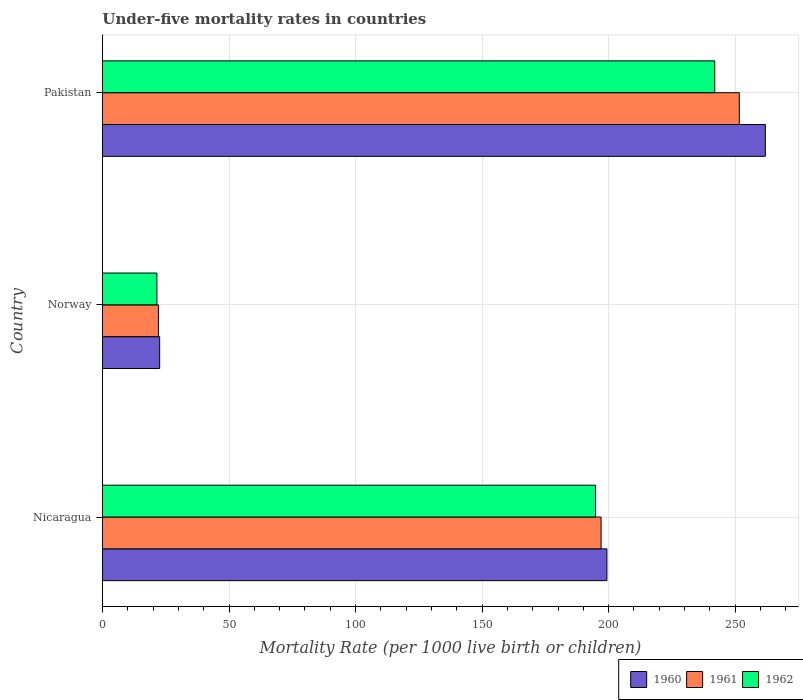Are the number of bars on each tick of the Y-axis equal?
Offer a terse response. Yes. What is the label of the 3rd group of bars from the top?
Ensure brevity in your answer.  Nicaragua. In how many cases, is the number of bars for a given country not equal to the number of legend labels?
Your answer should be compact. 0. What is the under-five mortality rate in 1961 in Nicaragua?
Your answer should be compact. 197. Across all countries, what is the maximum under-five mortality rate in 1960?
Keep it short and to the point. 261.9. Across all countries, what is the minimum under-five mortality rate in 1962?
Provide a short and direct response. 21.5. In which country was the under-five mortality rate in 1961 maximum?
Offer a terse response. Pakistan. What is the total under-five mortality rate in 1962 in the graph?
Provide a succinct answer. 458.2. What is the difference between the under-five mortality rate in 1962 in Nicaragua and that in Norway?
Give a very brief answer. 173.3. What is the difference between the under-five mortality rate in 1961 in Nicaragua and the under-five mortality rate in 1960 in Norway?
Provide a succinct answer. 174.4. What is the average under-five mortality rate in 1961 per country?
Keep it short and to the point. 156.9. What is the difference between the under-five mortality rate in 1962 and under-five mortality rate in 1961 in Nicaragua?
Offer a very short reply. -2.2. What is the ratio of the under-five mortality rate in 1962 in Nicaragua to that in Norway?
Your response must be concise. 9.06. What is the difference between the highest and the second highest under-five mortality rate in 1962?
Give a very brief answer. 47.1. What is the difference between the highest and the lowest under-five mortality rate in 1960?
Offer a terse response. 239.3. Is the sum of the under-five mortality rate in 1961 in Nicaragua and Norway greater than the maximum under-five mortality rate in 1962 across all countries?
Give a very brief answer. No. How many bars are there?
Provide a succinct answer. 9. Are all the bars in the graph horizontal?
Your answer should be compact. Yes. What is the difference between two consecutive major ticks on the X-axis?
Offer a very short reply. 50. Are the values on the major ticks of X-axis written in scientific E-notation?
Your answer should be very brief. No. How are the legend labels stacked?
Your answer should be very brief. Horizontal. What is the title of the graph?
Make the answer very short. Under-five mortality rates in countries. Does "2008" appear as one of the legend labels in the graph?
Offer a very short reply. No. What is the label or title of the X-axis?
Your answer should be very brief. Mortality Rate (per 1000 live birth or children). What is the label or title of the Y-axis?
Provide a short and direct response. Country. What is the Mortality Rate (per 1000 live birth or children) in 1960 in Nicaragua?
Keep it short and to the point. 199.3. What is the Mortality Rate (per 1000 live birth or children) of 1961 in Nicaragua?
Keep it short and to the point. 197. What is the Mortality Rate (per 1000 live birth or children) in 1962 in Nicaragua?
Ensure brevity in your answer.  194.8. What is the Mortality Rate (per 1000 live birth or children) of 1960 in Norway?
Your answer should be compact. 22.6. What is the Mortality Rate (per 1000 live birth or children) of 1961 in Norway?
Provide a succinct answer. 22.1. What is the Mortality Rate (per 1000 live birth or children) of 1960 in Pakistan?
Make the answer very short. 261.9. What is the Mortality Rate (per 1000 live birth or children) in 1961 in Pakistan?
Provide a succinct answer. 251.6. What is the Mortality Rate (per 1000 live birth or children) in 1962 in Pakistan?
Ensure brevity in your answer.  241.9. Across all countries, what is the maximum Mortality Rate (per 1000 live birth or children) in 1960?
Provide a succinct answer. 261.9. Across all countries, what is the maximum Mortality Rate (per 1000 live birth or children) of 1961?
Offer a very short reply. 251.6. Across all countries, what is the maximum Mortality Rate (per 1000 live birth or children) of 1962?
Offer a very short reply. 241.9. Across all countries, what is the minimum Mortality Rate (per 1000 live birth or children) of 1960?
Keep it short and to the point. 22.6. Across all countries, what is the minimum Mortality Rate (per 1000 live birth or children) of 1961?
Give a very brief answer. 22.1. Across all countries, what is the minimum Mortality Rate (per 1000 live birth or children) in 1962?
Provide a succinct answer. 21.5. What is the total Mortality Rate (per 1000 live birth or children) of 1960 in the graph?
Give a very brief answer. 483.8. What is the total Mortality Rate (per 1000 live birth or children) of 1961 in the graph?
Your answer should be very brief. 470.7. What is the total Mortality Rate (per 1000 live birth or children) in 1962 in the graph?
Your response must be concise. 458.2. What is the difference between the Mortality Rate (per 1000 live birth or children) in 1960 in Nicaragua and that in Norway?
Provide a succinct answer. 176.7. What is the difference between the Mortality Rate (per 1000 live birth or children) in 1961 in Nicaragua and that in Norway?
Make the answer very short. 174.9. What is the difference between the Mortality Rate (per 1000 live birth or children) in 1962 in Nicaragua and that in Norway?
Ensure brevity in your answer.  173.3. What is the difference between the Mortality Rate (per 1000 live birth or children) of 1960 in Nicaragua and that in Pakistan?
Ensure brevity in your answer.  -62.6. What is the difference between the Mortality Rate (per 1000 live birth or children) of 1961 in Nicaragua and that in Pakistan?
Provide a short and direct response. -54.6. What is the difference between the Mortality Rate (per 1000 live birth or children) of 1962 in Nicaragua and that in Pakistan?
Offer a terse response. -47.1. What is the difference between the Mortality Rate (per 1000 live birth or children) of 1960 in Norway and that in Pakistan?
Ensure brevity in your answer.  -239.3. What is the difference between the Mortality Rate (per 1000 live birth or children) of 1961 in Norway and that in Pakistan?
Your response must be concise. -229.5. What is the difference between the Mortality Rate (per 1000 live birth or children) in 1962 in Norway and that in Pakistan?
Offer a very short reply. -220.4. What is the difference between the Mortality Rate (per 1000 live birth or children) in 1960 in Nicaragua and the Mortality Rate (per 1000 live birth or children) in 1961 in Norway?
Ensure brevity in your answer.  177.2. What is the difference between the Mortality Rate (per 1000 live birth or children) of 1960 in Nicaragua and the Mortality Rate (per 1000 live birth or children) of 1962 in Norway?
Your answer should be compact. 177.8. What is the difference between the Mortality Rate (per 1000 live birth or children) of 1961 in Nicaragua and the Mortality Rate (per 1000 live birth or children) of 1962 in Norway?
Your answer should be very brief. 175.5. What is the difference between the Mortality Rate (per 1000 live birth or children) of 1960 in Nicaragua and the Mortality Rate (per 1000 live birth or children) of 1961 in Pakistan?
Keep it short and to the point. -52.3. What is the difference between the Mortality Rate (per 1000 live birth or children) of 1960 in Nicaragua and the Mortality Rate (per 1000 live birth or children) of 1962 in Pakistan?
Offer a terse response. -42.6. What is the difference between the Mortality Rate (per 1000 live birth or children) in 1961 in Nicaragua and the Mortality Rate (per 1000 live birth or children) in 1962 in Pakistan?
Offer a very short reply. -44.9. What is the difference between the Mortality Rate (per 1000 live birth or children) in 1960 in Norway and the Mortality Rate (per 1000 live birth or children) in 1961 in Pakistan?
Make the answer very short. -229. What is the difference between the Mortality Rate (per 1000 live birth or children) of 1960 in Norway and the Mortality Rate (per 1000 live birth or children) of 1962 in Pakistan?
Keep it short and to the point. -219.3. What is the difference between the Mortality Rate (per 1000 live birth or children) of 1961 in Norway and the Mortality Rate (per 1000 live birth or children) of 1962 in Pakistan?
Ensure brevity in your answer.  -219.8. What is the average Mortality Rate (per 1000 live birth or children) in 1960 per country?
Your answer should be very brief. 161.27. What is the average Mortality Rate (per 1000 live birth or children) of 1961 per country?
Provide a succinct answer. 156.9. What is the average Mortality Rate (per 1000 live birth or children) in 1962 per country?
Provide a succinct answer. 152.73. What is the difference between the Mortality Rate (per 1000 live birth or children) of 1960 and Mortality Rate (per 1000 live birth or children) of 1962 in Nicaragua?
Your answer should be compact. 4.5. What is the difference between the Mortality Rate (per 1000 live birth or children) of 1961 and Mortality Rate (per 1000 live birth or children) of 1962 in Nicaragua?
Provide a succinct answer. 2.2. What is the difference between the Mortality Rate (per 1000 live birth or children) of 1960 and Mortality Rate (per 1000 live birth or children) of 1962 in Norway?
Provide a short and direct response. 1.1. What is the difference between the Mortality Rate (per 1000 live birth or children) of 1961 and Mortality Rate (per 1000 live birth or children) of 1962 in Pakistan?
Your answer should be very brief. 9.7. What is the ratio of the Mortality Rate (per 1000 live birth or children) in 1960 in Nicaragua to that in Norway?
Your answer should be very brief. 8.82. What is the ratio of the Mortality Rate (per 1000 live birth or children) of 1961 in Nicaragua to that in Norway?
Offer a very short reply. 8.91. What is the ratio of the Mortality Rate (per 1000 live birth or children) of 1962 in Nicaragua to that in Norway?
Provide a succinct answer. 9.06. What is the ratio of the Mortality Rate (per 1000 live birth or children) of 1960 in Nicaragua to that in Pakistan?
Ensure brevity in your answer.  0.76. What is the ratio of the Mortality Rate (per 1000 live birth or children) in 1961 in Nicaragua to that in Pakistan?
Provide a succinct answer. 0.78. What is the ratio of the Mortality Rate (per 1000 live birth or children) in 1962 in Nicaragua to that in Pakistan?
Provide a succinct answer. 0.81. What is the ratio of the Mortality Rate (per 1000 live birth or children) of 1960 in Norway to that in Pakistan?
Offer a terse response. 0.09. What is the ratio of the Mortality Rate (per 1000 live birth or children) in 1961 in Norway to that in Pakistan?
Your answer should be very brief. 0.09. What is the ratio of the Mortality Rate (per 1000 live birth or children) of 1962 in Norway to that in Pakistan?
Ensure brevity in your answer.  0.09. What is the difference between the highest and the second highest Mortality Rate (per 1000 live birth or children) of 1960?
Provide a succinct answer. 62.6. What is the difference between the highest and the second highest Mortality Rate (per 1000 live birth or children) in 1961?
Provide a succinct answer. 54.6. What is the difference between the highest and the second highest Mortality Rate (per 1000 live birth or children) in 1962?
Make the answer very short. 47.1. What is the difference between the highest and the lowest Mortality Rate (per 1000 live birth or children) of 1960?
Offer a very short reply. 239.3. What is the difference between the highest and the lowest Mortality Rate (per 1000 live birth or children) in 1961?
Give a very brief answer. 229.5. What is the difference between the highest and the lowest Mortality Rate (per 1000 live birth or children) of 1962?
Offer a very short reply. 220.4. 